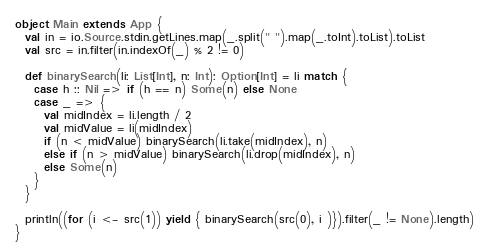<code> <loc_0><loc_0><loc_500><loc_500><_Scala_>object Main extends App {
  val in = io.Source.stdin.getLines.map(_.split(" ").map(_.toInt).toList).toList
  val src = in.filter(in.indexOf(_) % 2 != 0)

  def binarySearch(li: List[Int], n: Int): Option[Int] = li match {
    case h :: Nil => if (h == n) Some(n) else None
    case _ => {
      val midIndex = li.length / 2
      val midValue = li(midIndex)
      if (n < midValue) binarySearch(li.take(midIndex), n)
      else if (n > midValue) binarySearch(li.drop(midIndex), n)
      else Some(n)
    }
  }

  println((for (i <- src(1)) yield { binarySearch(src(0), i )}).filter(_ != None).length)
}

</code> 